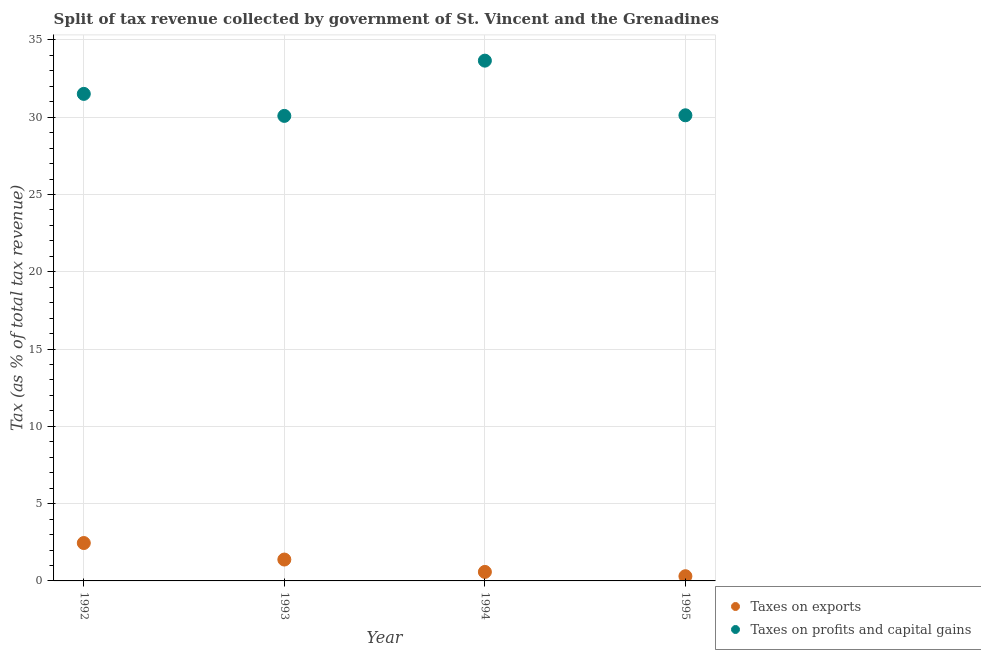Is the number of dotlines equal to the number of legend labels?
Ensure brevity in your answer.  Yes. What is the percentage of revenue obtained from taxes on profits and capital gains in 1994?
Your answer should be compact. 33.66. Across all years, what is the maximum percentage of revenue obtained from taxes on profits and capital gains?
Your answer should be very brief. 33.66. Across all years, what is the minimum percentage of revenue obtained from taxes on profits and capital gains?
Make the answer very short. 30.08. What is the total percentage of revenue obtained from taxes on exports in the graph?
Keep it short and to the point. 4.72. What is the difference between the percentage of revenue obtained from taxes on exports in 1992 and that in 1994?
Keep it short and to the point. 1.87. What is the difference between the percentage of revenue obtained from taxes on profits and capital gains in 1993 and the percentage of revenue obtained from taxes on exports in 1995?
Ensure brevity in your answer.  29.78. What is the average percentage of revenue obtained from taxes on profits and capital gains per year?
Offer a terse response. 31.34. In the year 1992, what is the difference between the percentage of revenue obtained from taxes on profits and capital gains and percentage of revenue obtained from taxes on exports?
Offer a terse response. 29.06. In how many years, is the percentage of revenue obtained from taxes on exports greater than 26 %?
Give a very brief answer. 0. What is the ratio of the percentage of revenue obtained from taxes on profits and capital gains in 1992 to that in 1993?
Your answer should be very brief. 1.05. Is the difference between the percentage of revenue obtained from taxes on exports in 1993 and 1994 greater than the difference between the percentage of revenue obtained from taxes on profits and capital gains in 1993 and 1994?
Your answer should be compact. Yes. What is the difference between the highest and the second highest percentage of revenue obtained from taxes on exports?
Make the answer very short. 1.07. What is the difference between the highest and the lowest percentage of revenue obtained from taxes on exports?
Give a very brief answer. 2.15. Is the sum of the percentage of revenue obtained from taxes on exports in 1992 and 1995 greater than the maximum percentage of revenue obtained from taxes on profits and capital gains across all years?
Make the answer very short. No. Does the percentage of revenue obtained from taxes on exports monotonically increase over the years?
Your answer should be compact. No. Is the percentage of revenue obtained from taxes on profits and capital gains strictly greater than the percentage of revenue obtained from taxes on exports over the years?
Your response must be concise. Yes. What is the difference between two consecutive major ticks on the Y-axis?
Your answer should be compact. 5. Are the values on the major ticks of Y-axis written in scientific E-notation?
Keep it short and to the point. No. Does the graph contain any zero values?
Ensure brevity in your answer.  No. Where does the legend appear in the graph?
Make the answer very short. Bottom right. What is the title of the graph?
Your response must be concise. Split of tax revenue collected by government of St. Vincent and the Grenadines. Does "current US$" appear as one of the legend labels in the graph?
Provide a short and direct response. No. What is the label or title of the X-axis?
Offer a very short reply. Year. What is the label or title of the Y-axis?
Offer a terse response. Tax (as % of total tax revenue). What is the Tax (as % of total tax revenue) in Taxes on exports in 1992?
Keep it short and to the point. 2.45. What is the Tax (as % of total tax revenue) of Taxes on profits and capital gains in 1992?
Give a very brief answer. 31.51. What is the Tax (as % of total tax revenue) in Taxes on exports in 1993?
Make the answer very short. 1.38. What is the Tax (as % of total tax revenue) in Taxes on profits and capital gains in 1993?
Offer a very short reply. 30.08. What is the Tax (as % of total tax revenue) in Taxes on exports in 1994?
Provide a succinct answer. 0.58. What is the Tax (as % of total tax revenue) in Taxes on profits and capital gains in 1994?
Provide a succinct answer. 33.66. What is the Tax (as % of total tax revenue) of Taxes on exports in 1995?
Give a very brief answer. 0.3. What is the Tax (as % of total tax revenue) of Taxes on profits and capital gains in 1995?
Provide a short and direct response. 30.12. Across all years, what is the maximum Tax (as % of total tax revenue) of Taxes on exports?
Keep it short and to the point. 2.45. Across all years, what is the maximum Tax (as % of total tax revenue) of Taxes on profits and capital gains?
Keep it short and to the point. 33.66. Across all years, what is the minimum Tax (as % of total tax revenue) in Taxes on exports?
Keep it short and to the point. 0.3. Across all years, what is the minimum Tax (as % of total tax revenue) in Taxes on profits and capital gains?
Offer a very short reply. 30.08. What is the total Tax (as % of total tax revenue) in Taxes on exports in the graph?
Keep it short and to the point. 4.72. What is the total Tax (as % of total tax revenue) in Taxes on profits and capital gains in the graph?
Provide a succinct answer. 125.37. What is the difference between the Tax (as % of total tax revenue) in Taxes on exports in 1992 and that in 1993?
Offer a terse response. 1.07. What is the difference between the Tax (as % of total tax revenue) of Taxes on profits and capital gains in 1992 and that in 1993?
Keep it short and to the point. 1.42. What is the difference between the Tax (as % of total tax revenue) of Taxes on exports in 1992 and that in 1994?
Your response must be concise. 1.87. What is the difference between the Tax (as % of total tax revenue) of Taxes on profits and capital gains in 1992 and that in 1994?
Make the answer very short. -2.15. What is the difference between the Tax (as % of total tax revenue) in Taxes on exports in 1992 and that in 1995?
Provide a succinct answer. 2.15. What is the difference between the Tax (as % of total tax revenue) of Taxes on profits and capital gains in 1992 and that in 1995?
Make the answer very short. 1.38. What is the difference between the Tax (as % of total tax revenue) of Taxes on exports in 1993 and that in 1994?
Provide a succinct answer. 0.8. What is the difference between the Tax (as % of total tax revenue) in Taxes on profits and capital gains in 1993 and that in 1994?
Your answer should be compact. -3.57. What is the difference between the Tax (as % of total tax revenue) of Taxes on exports in 1993 and that in 1995?
Your answer should be very brief. 1.08. What is the difference between the Tax (as % of total tax revenue) in Taxes on profits and capital gains in 1993 and that in 1995?
Offer a terse response. -0.04. What is the difference between the Tax (as % of total tax revenue) of Taxes on exports in 1994 and that in 1995?
Provide a short and direct response. 0.28. What is the difference between the Tax (as % of total tax revenue) of Taxes on profits and capital gains in 1994 and that in 1995?
Provide a short and direct response. 3.54. What is the difference between the Tax (as % of total tax revenue) in Taxes on exports in 1992 and the Tax (as % of total tax revenue) in Taxes on profits and capital gains in 1993?
Your answer should be very brief. -27.63. What is the difference between the Tax (as % of total tax revenue) in Taxes on exports in 1992 and the Tax (as % of total tax revenue) in Taxes on profits and capital gains in 1994?
Your answer should be compact. -31.21. What is the difference between the Tax (as % of total tax revenue) in Taxes on exports in 1992 and the Tax (as % of total tax revenue) in Taxes on profits and capital gains in 1995?
Give a very brief answer. -27.67. What is the difference between the Tax (as % of total tax revenue) in Taxes on exports in 1993 and the Tax (as % of total tax revenue) in Taxes on profits and capital gains in 1994?
Provide a succinct answer. -32.27. What is the difference between the Tax (as % of total tax revenue) of Taxes on exports in 1993 and the Tax (as % of total tax revenue) of Taxes on profits and capital gains in 1995?
Offer a terse response. -28.74. What is the difference between the Tax (as % of total tax revenue) in Taxes on exports in 1994 and the Tax (as % of total tax revenue) in Taxes on profits and capital gains in 1995?
Your answer should be compact. -29.54. What is the average Tax (as % of total tax revenue) of Taxes on exports per year?
Offer a terse response. 1.18. What is the average Tax (as % of total tax revenue) in Taxes on profits and capital gains per year?
Provide a succinct answer. 31.34. In the year 1992, what is the difference between the Tax (as % of total tax revenue) of Taxes on exports and Tax (as % of total tax revenue) of Taxes on profits and capital gains?
Your answer should be compact. -29.06. In the year 1993, what is the difference between the Tax (as % of total tax revenue) of Taxes on exports and Tax (as % of total tax revenue) of Taxes on profits and capital gains?
Ensure brevity in your answer.  -28.7. In the year 1994, what is the difference between the Tax (as % of total tax revenue) of Taxes on exports and Tax (as % of total tax revenue) of Taxes on profits and capital gains?
Provide a succinct answer. -33.07. In the year 1995, what is the difference between the Tax (as % of total tax revenue) of Taxes on exports and Tax (as % of total tax revenue) of Taxes on profits and capital gains?
Your response must be concise. -29.82. What is the ratio of the Tax (as % of total tax revenue) in Taxes on exports in 1992 to that in 1993?
Your answer should be compact. 1.77. What is the ratio of the Tax (as % of total tax revenue) of Taxes on profits and capital gains in 1992 to that in 1993?
Offer a terse response. 1.05. What is the ratio of the Tax (as % of total tax revenue) of Taxes on exports in 1992 to that in 1994?
Your answer should be compact. 4.21. What is the ratio of the Tax (as % of total tax revenue) of Taxes on profits and capital gains in 1992 to that in 1994?
Provide a succinct answer. 0.94. What is the ratio of the Tax (as % of total tax revenue) of Taxes on exports in 1992 to that in 1995?
Your response must be concise. 8.04. What is the ratio of the Tax (as % of total tax revenue) of Taxes on profits and capital gains in 1992 to that in 1995?
Offer a terse response. 1.05. What is the ratio of the Tax (as % of total tax revenue) of Taxes on exports in 1993 to that in 1994?
Provide a short and direct response. 2.37. What is the ratio of the Tax (as % of total tax revenue) in Taxes on profits and capital gains in 1993 to that in 1994?
Your answer should be compact. 0.89. What is the ratio of the Tax (as % of total tax revenue) of Taxes on exports in 1993 to that in 1995?
Your response must be concise. 4.54. What is the ratio of the Tax (as % of total tax revenue) of Taxes on exports in 1994 to that in 1995?
Give a very brief answer. 1.91. What is the ratio of the Tax (as % of total tax revenue) of Taxes on profits and capital gains in 1994 to that in 1995?
Your response must be concise. 1.12. What is the difference between the highest and the second highest Tax (as % of total tax revenue) in Taxes on exports?
Your answer should be compact. 1.07. What is the difference between the highest and the second highest Tax (as % of total tax revenue) of Taxes on profits and capital gains?
Your answer should be compact. 2.15. What is the difference between the highest and the lowest Tax (as % of total tax revenue) of Taxes on exports?
Provide a succinct answer. 2.15. What is the difference between the highest and the lowest Tax (as % of total tax revenue) in Taxes on profits and capital gains?
Your answer should be very brief. 3.57. 